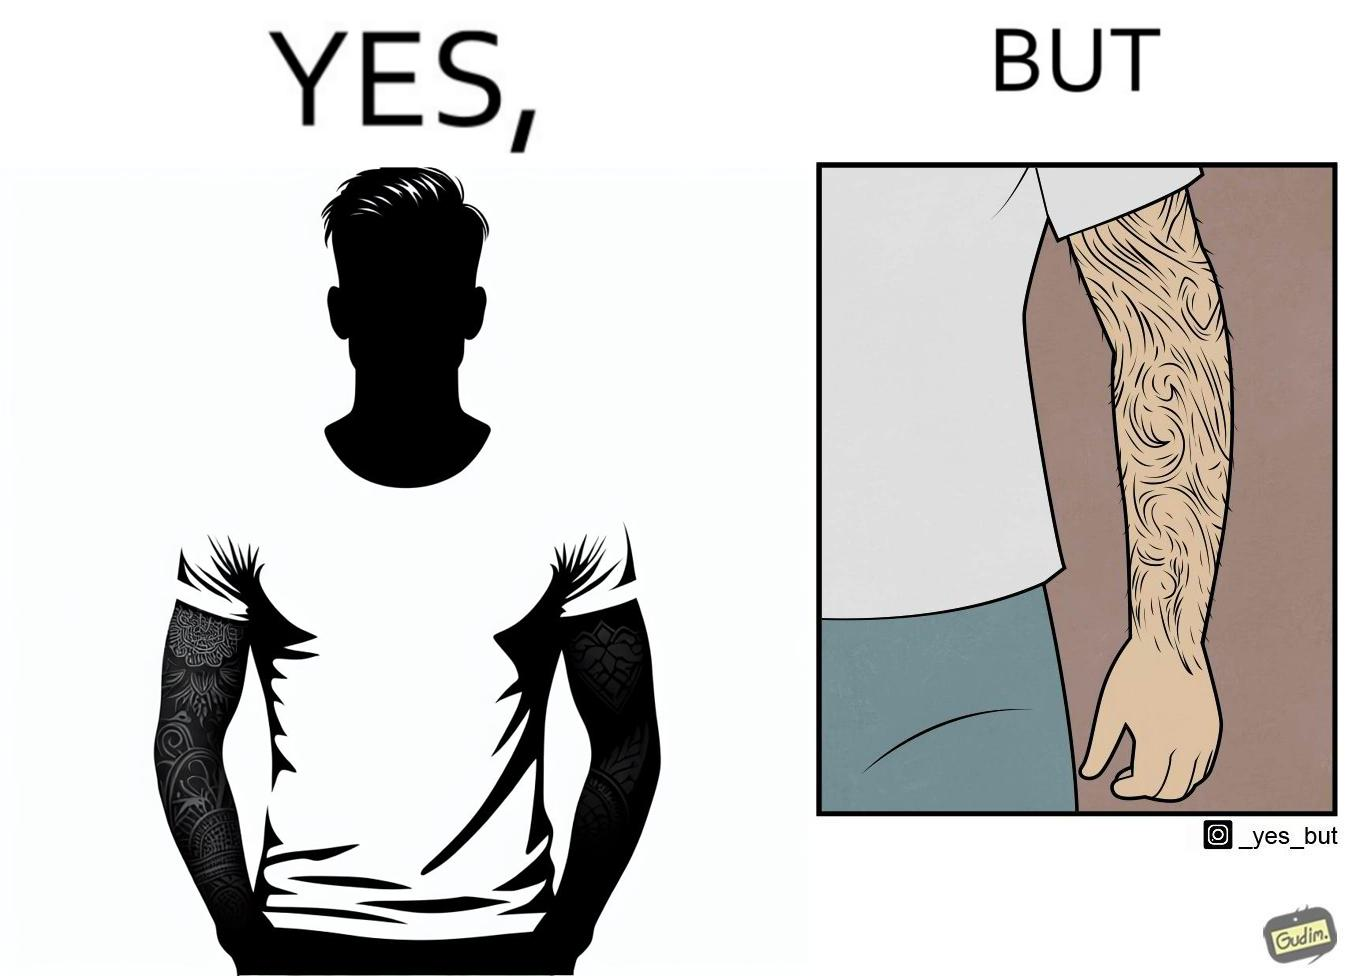Describe what you see in this image. The image is funny because while from the distance it seems that the man has big tattoos on both of his arms upon a closer look at the arms it turns out there is no tattoo and what seemed to be tattoos are just hairs on his arm. 